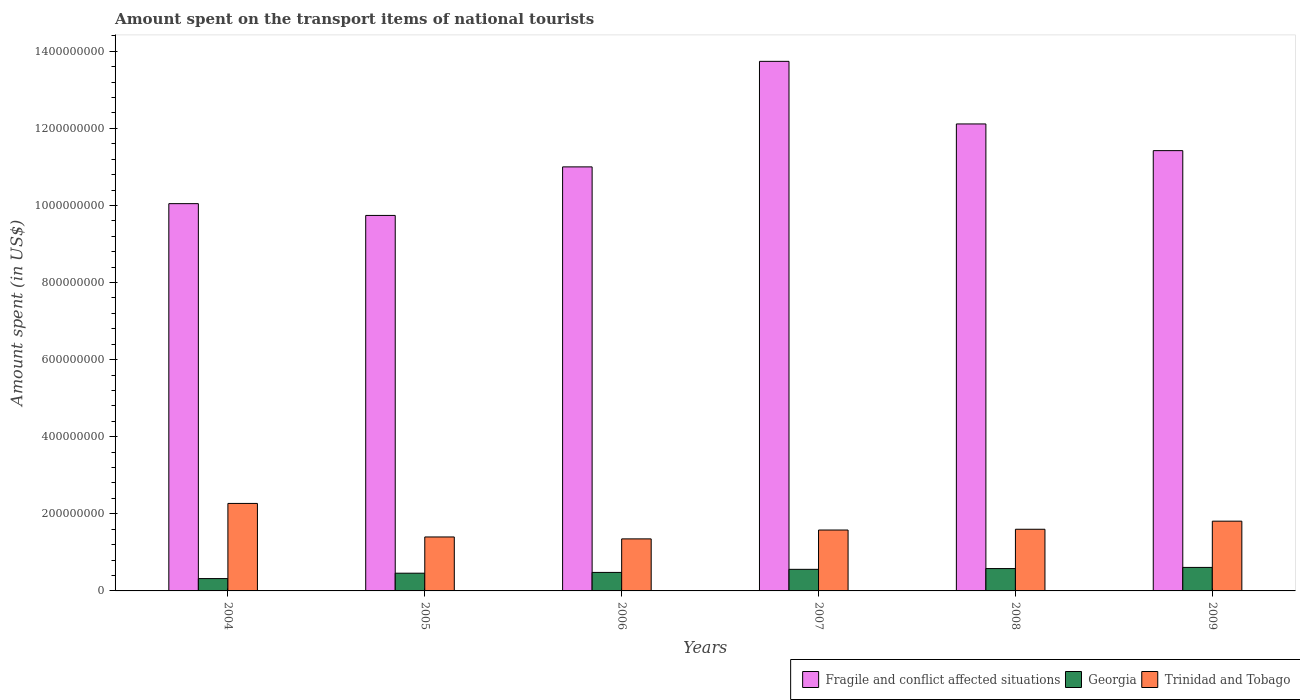Are the number of bars per tick equal to the number of legend labels?
Your answer should be very brief. Yes. How many bars are there on the 6th tick from the right?
Offer a terse response. 3. In how many cases, is the number of bars for a given year not equal to the number of legend labels?
Keep it short and to the point. 0. What is the amount spent on the transport items of national tourists in Georgia in 2005?
Provide a succinct answer. 4.60e+07. Across all years, what is the maximum amount spent on the transport items of national tourists in Fragile and conflict affected situations?
Your response must be concise. 1.37e+09. Across all years, what is the minimum amount spent on the transport items of national tourists in Georgia?
Keep it short and to the point. 3.20e+07. In which year was the amount spent on the transport items of national tourists in Trinidad and Tobago maximum?
Keep it short and to the point. 2004. In which year was the amount spent on the transport items of national tourists in Fragile and conflict affected situations minimum?
Offer a terse response. 2005. What is the total amount spent on the transport items of national tourists in Trinidad and Tobago in the graph?
Ensure brevity in your answer.  1.00e+09. What is the difference between the amount spent on the transport items of national tourists in Georgia in 2007 and the amount spent on the transport items of national tourists in Fragile and conflict affected situations in 2004?
Your answer should be compact. -9.49e+08. What is the average amount spent on the transport items of national tourists in Fragile and conflict affected situations per year?
Ensure brevity in your answer.  1.13e+09. In the year 2009, what is the difference between the amount spent on the transport items of national tourists in Trinidad and Tobago and amount spent on the transport items of national tourists in Georgia?
Ensure brevity in your answer.  1.20e+08. In how many years, is the amount spent on the transport items of national tourists in Georgia greater than 560000000 US$?
Provide a succinct answer. 0. What is the ratio of the amount spent on the transport items of national tourists in Trinidad and Tobago in 2005 to that in 2008?
Provide a succinct answer. 0.88. Is the amount spent on the transport items of national tourists in Fragile and conflict affected situations in 2008 less than that in 2009?
Your answer should be compact. No. Is the difference between the amount spent on the transport items of national tourists in Trinidad and Tobago in 2006 and 2008 greater than the difference between the amount spent on the transport items of national tourists in Georgia in 2006 and 2008?
Your answer should be very brief. No. What is the difference between the highest and the second highest amount spent on the transport items of national tourists in Fragile and conflict affected situations?
Your answer should be compact. 1.62e+08. What is the difference between the highest and the lowest amount spent on the transport items of national tourists in Georgia?
Ensure brevity in your answer.  2.90e+07. In how many years, is the amount spent on the transport items of national tourists in Trinidad and Tobago greater than the average amount spent on the transport items of national tourists in Trinidad and Tobago taken over all years?
Offer a very short reply. 2. Is the sum of the amount spent on the transport items of national tourists in Trinidad and Tobago in 2004 and 2008 greater than the maximum amount spent on the transport items of national tourists in Georgia across all years?
Your answer should be compact. Yes. What does the 2nd bar from the left in 2005 represents?
Your response must be concise. Georgia. What does the 2nd bar from the right in 2004 represents?
Your answer should be compact. Georgia. Is it the case that in every year, the sum of the amount spent on the transport items of national tourists in Georgia and amount spent on the transport items of national tourists in Trinidad and Tobago is greater than the amount spent on the transport items of national tourists in Fragile and conflict affected situations?
Ensure brevity in your answer.  No. How many bars are there?
Provide a succinct answer. 18. Are all the bars in the graph horizontal?
Provide a short and direct response. No. How many years are there in the graph?
Your response must be concise. 6. Are the values on the major ticks of Y-axis written in scientific E-notation?
Provide a short and direct response. No. What is the title of the graph?
Your response must be concise. Amount spent on the transport items of national tourists. Does "Bahamas" appear as one of the legend labels in the graph?
Provide a succinct answer. No. What is the label or title of the X-axis?
Offer a very short reply. Years. What is the label or title of the Y-axis?
Give a very brief answer. Amount spent (in US$). What is the Amount spent (in US$) in Fragile and conflict affected situations in 2004?
Provide a short and direct response. 1.00e+09. What is the Amount spent (in US$) of Georgia in 2004?
Your answer should be compact. 3.20e+07. What is the Amount spent (in US$) of Trinidad and Tobago in 2004?
Give a very brief answer. 2.27e+08. What is the Amount spent (in US$) in Fragile and conflict affected situations in 2005?
Your answer should be compact. 9.74e+08. What is the Amount spent (in US$) of Georgia in 2005?
Provide a succinct answer. 4.60e+07. What is the Amount spent (in US$) of Trinidad and Tobago in 2005?
Provide a short and direct response. 1.40e+08. What is the Amount spent (in US$) of Fragile and conflict affected situations in 2006?
Offer a very short reply. 1.10e+09. What is the Amount spent (in US$) in Georgia in 2006?
Your response must be concise. 4.80e+07. What is the Amount spent (in US$) in Trinidad and Tobago in 2006?
Ensure brevity in your answer.  1.35e+08. What is the Amount spent (in US$) in Fragile and conflict affected situations in 2007?
Your response must be concise. 1.37e+09. What is the Amount spent (in US$) in Georgia in 2007?
Keep it short and to the point. 5.60e+07. What is the Amount spent (in US$) of Trinidad and Tobago in 2007?
Your response must be concise. 1.58e+08. What is the Amount spent (in US$) in Fragile and conflict affected situations in 2008?
Give a very brief answer. 1.21e+09. What is the Amount spent (in US$) in Georgia in 2008?
Your answer should be compact. 5.80e+07. What is the Amount spent (in US$) in Trinidad and Tobago in 2008?
Your answer should be compact. 1.60e+08. What is the Amount spent (in US$) of Fragile and conflict affected situations in 2009?
Give a very brief answer. 1.14e+09. What is the Amount spent (in US$) of Georgia in 2009?
Your answer should be compact. 6.10e+07. What is the Amount spent (in US$) of Trinidad and Tobago in 2009?
Provide a succinct answer. 1.81e+08. Across all years, what is the maximum Amount spent (in US$) of Fragile and conflict affected situations?
Keep it short and to the point. 1.37e+09. Across all years, what is the maximum Amount spent (in US$) in Georgia?
Your answer should be compact. 6.10e+07. Across all years, what is the maximum Amount spent (in US$) of Trinidad and Tobago?
Keep it short and to the point. 2.27e+08. Across all years, what is the minimum Amount spent (in US$) of Fragile and conflict affected situations?
Provide a short and direct response. 9.74e+08. Across all years, what is the minimum Amount spent (in US$) in Georgia?
Keep it short and to the point. 3.20e+07. Across all years, what is the minimum Amount spent (in US$) of Trinidad and Tobago?
Make the answer very short. 1.35e+08. What is the total Amount spent (in US$) in Fragile and conflict affected situations in the graph?
Your answer should be compact. 6.81e+09. What is the total Amount spent (in US$) of Georgia in the graph?
Make the answer very short. 3.01e+08. What is the total Amount spent (in US$) in Trinidad and Tobago in the graph?
Keep it short and to the point. 1.00e+09. What is the difference between the Amount spent (in US$) of Fragile and conflict affected situations in 2004 and that in 2005?
Make the answer very short. 3.06e+07. What is the difference between the Amount spent (in US$) of Georgia in 2004 and that in 2005?
Your answer should be compact. -1.40e+07. What is the difference between the Amount spent (in US$) in Trinidad and Tobago in 2004 and that in 2005?
Your answer should be very brief. 8.70e+07. What is the difference between the Amount spent (in US$) of Fragile and conflict affected situations in 2004 and that in 2006?
Offer a terse response. -9.54e+07. What is the difference between the Amount spent (in US$) in Georgia in 2004 and that in 2006?
Your answer should be very brief. -1.60e+07. What is the difference between the Amount spent (in US$) in Trinidad and Tobago in 2004 and that in 2006?
Make the answer very short. 9.20e+07. What is the difference between the Amount spent (in US$) in Fragile and conflict affected situations in 2004 and that in 2007?
Provide a succinct answer. -3.69e+08. What is the difference between the Amount spent (in US$) of Georgia in 2004 and that in 2007?
Provide a succinct answer. -2.40e+07. What is the difference between the Amount spent (in US$) of Trinidad and Tobago in 2004 and that in 2007?
Offer a terse response. 6.90e+07. What is the difference between the Amount spent (in US$) of Fragile and conflict affected situations in 2004 and that in 2008?
Ensure brevity in your answer.  -2.07e+08. What is the difference between the Amount spent (in US$) of Georgia in 2004 and that in 2008?
Provide a succinct answer. -2.60e+07. What is the difference between the Amount spent (in US$) of Trinidad and Tobago in 2004 and that in 2008?
Provide a succinct answer. 6.70e+07. What is the difference between the Amount spent (in US$) in Fragile and conflict affected situations in 2004 and that in 2009?
Your response must be concise. -1.38e+08. What is the difference between the Amount spent (in US$) of Georgia in 2004 and that in 2009?
Provide a succinct answer. -2.90e+07. What is the difference between the Amount spent (in US$) of Trinidad and Tobago in 2004 and that in 2009?
Your answer should be very brief. 4.60e+07. What is the difference between the Amount spent (in US$) of Fragile and conflict affected situations in 2005 and that in 2006?
Ensure brevity in your answer.  -1.26e+08. What is the difference between the Amount spent (in US$) of Georgia in 2005 and that in 2006?
Make the answer very short. -2.00e+06. What is the difference between the Amount spent (in US$) in Trinidad and Tobago in 2005 and that in 2006?
Give a very brief answer. 5.00e+06. What is the difference between the Amount spent (in US$) in Fragile and conflict affected situations in 2005 and that in 2007?
Provide a short and direct response. -4.00e+08. What is the difference between the Amount spent (in US$) of Georgia in 2005 and that in 2007?
Your answer should be compact. -1.00e+07. What is the difference between the Amount spent (in US$) in Trinidad and Tobago in 2005 and that in 2007?
Keep it short and to the point. -1.80e+07. What is the difference between the Amount spent (in US$) of Fragile and conflict affected situations in 2005 and that in 2008?
Give a very brief answer. -2.37e+08. What is the difference between the Amount spent (in US$) of Georgia in 2005 and that in 2008?
Keep it short and to the point. -1.20e+07. What is the difference between the Amount spent (in US$) of Trinidad and Tobago in 2005 and that in 2008?
Your answer should be very brief. -2.00e+07. What is the difference between the Amount spent (in US$) in Fragile and conflict affected situations in 2005 and that in 2009?
Offer a very short reply. -1.68e+08. What is the difference between the Amount spent (in US$) in Georgia in 2005 and that in 2009?
Your answer should be very brief. -1.50e+07. What is the difference between the Amount spent (in US$) in Trinidad and Tobago in 2005 and that in 2009?
Make the answer very short. -4.10e+07. What is the difference between the Amount spent (in US$) in Fragile and conflict affected situations in 2006 and that in 2007?
Offer a very short reply. -2.74e+08. What is the difference between the Amount spent (in US$) of Georgia in 2006 and that in 2007?
Keep it short and to the point. -8.00e+06. What is the difference between the Amount spent (in US$) of Trinidad and Tobago in 2006 and that in 2007?
Keep it short and to the point. -2.30e+07. What is the difference between the Amount spent (in US$) in Fragile and conflict affected situations in 2006 and that in 2008?
Your answer should be very brief. -1.11e+08. What is the difference between the Amount spent (in US$) of Georgia in 2006 and that in 2008?
Provide a succinct answer. -1.00e+07. What is the difference between the Amount spent (in US$) in Trinidad and Tobago in 2006 and that in 2008?
Provide a succinct answer. -2.50e+07. What is the difference between the Amount spent (in US$) in Fragile and conflict affected situations in 2006 and that in 2009?
Your answer should be very brief. -4.22e+07. What is the difference between the Amount spent (in US$) in Georgia in 2006 and that in 2009?
Give a very brief answer. -1.30e+07. What is the difference between the Amount spent (in US$) in Trinidad and Tobago in 2006 and that in 2009?
Your answer should be compact. -4.60e+07. What is the difference between the Amount spent (in US$) in Fragile and conflict affected situations in 2007 and that in 2008?
Provide a succinct answer. 1.62e+08. What is the difference between the Amount spent (in US$) of Georgia in 2007 and that in 2008?
Provide a short and direct response. -2.00e+06. What is the difference between the Amount spent (in US$) in Fragile and conflict affected situations in 2007 and that in 2009?
Ensure brevity in your answer.  2.32e+08. What is the difference between the Amount spent (in US$) in Georgia in 2007 and that in 2009?
Provide a succinct answer. -5.00e+06. What is the difference between the Amount spent (in US$) of Trinidad and Tobago in 2007 and that in 2009?
Ensure brevity in your answer.  -2.30e+07. What is the difference between the Amount spent (in US$) of Fragile and conflict affected situations in 2008 and that in 2009?
Your response must be concise. 6.92e+07. What is the difference between the Amount spent (in US$) in Georgia in 2008 and that in 2009?
Your response must be concise. -3.00e+06. What is the difference between the Amount spent (in US$) in Trinidad and Tobago in 2008 and that in 2009?
Your answer should be very brief. -2.10e+07. What is the difference between the Amount spent (in US$) in Fragile and conflict affected situations in 2004 and the Amount spent (in US$) in Georgia in 2005?
Provide a succinct answer. 9.59e+08. What is the difference between the Amount spent (in US$) in Fragile and conflict affected situations in 2004 and the Amount spent (in US$) in Trinidad and Tobago in 2005?
Offer a very short reply. 8.65e+08. What is the difference between the Amount spent (in US$) in Georgia in 2004 and the Amount spent (in US$) in Trinidad and Tobago in 2005?
Your answer should be compact. -1.08e+08. What is the difference between the Amount spent (in US$) in Fragile and conflict affected situations in 2004 and the Amount spent (in US$) in Georgia in 2006?
Provide a succinct answer. 9.57e+08. What is the difference between the Amount spent (in US$) in Fragile and conflict affected situations in 2004 and the Amount spent (in US$) in Trinidad and Tobago in 2006?
Keep it short and to the point. 8.70e+08. What is the difference between the Amount spent (in US$) in Georgia in 2004 and the Amount spent (in US$) in Trinidad and Tobago in 2006?
Offer a terse response. -1.03e+08. What is the difference between the Amount spent (in US$) of Fragile and conflict affected situations in 2004 and the Amount spent (in US$) of Georgia in 2007?
Keep it short and to the point. 9.49e+08. What is the difference between the Amount spent (in US$) of Fragile and conflict affected situations in 2004 and the Amount spent (in US$) of Trinidad and Tobago in 2007?
Make the answer very short. 8.47e+08. What is the difference between the Amount spent (in US$) of Georgia in 2004 and the Amount spent (in US$) of Trinidad and Tobago in 2007?
Make the answer very short. -1.26e+08. What is the difference between the Amount spent (in US$) in Fragile and conflict affected situations in 2004 and the Amount spent (in US$) in Georgia in 2008?
Make the answer very short. 9.47e+08. What is the difference between the Amount spent (in US$) in Fragile and conflict affected situations in 2004 and the Amount spent (in US$) in Trinidad and Tobago in 2008?
Your answer should be very brief. 8.45e+08. What is the difference between the Amount spent (in US$) of Georgia in 2004 and the Amount spent (in US$) of Trinidad and Tobago in 2008?
Keep it short and to the point. -1.28e+08. What is the difference between the Amount spent (in US$) in Fragile and conflict affected situations in 2004 and the Amount spent (in US$) in Georgia in 2009?
Your answer should be very brief. 9.44e+08. What is the difference between the Amount spent (in US$) of Fragile and conflict affected situations in 2004 and the Amount spent (in US$) of Trinidad and Tobago in 2009?
Provide a succinct answer. 8.24e+08. What is the difference between the Amount spent (in US$) in Georgia in 2004 and the Amount spent (in US$) in Trinidad and Tobago in 2009?
Give a very brief answer. -1.49e+08. What is the difference between the Amount spent (in US$) of Fragile and conflict affected situations in 2005 and the Amount spent (in US$) of Georgia in 2006?
Offer a terse response. 9.26e+08. What is the difference between the Amount spent (in US$) in Fragile and conflict affected situations in 2005 and the Amount spent (in US$) in Trinidad and Tobago in 2006?
Offer a very short reply. 8.39e+08. What is the difference between the Amount spent (in US$) in Georgia in 2005 and the Amount spent (in US$) in Trinidad and Tobago in 2006?
Keep it short and to the point. -8.90e+07. What is the difference between the Amount spent (in US$) in Fragile and conflict affected situations in 2005 and the Amount spent (in US$) in Georgia in 2007?
Your answer should be very brief. 9.18e+08. What is the difference between the Amount spent (in US$) of Fragile and conflict affected situations in 2005 and the Amount spent (in US$) of Trinidad and Tobago in 2007?
Your answer should be compact. 8.16e+08. What is the difference between the Amount spent (in US$) of Georgia in 2005 and the Amount spent (in US$) of Trinidad and Tobago in 2007?
Keep it short and to the point. -1.12e+08. What is the difference between the Amount spent (in US$) in Fragile and conflict affected situations in 2005 and the Amount spent (in US$) in Georgia in 2008?
Provide a succinct answer. 9.16e+08. What is the difference between the Amount spent (in US$) of Fragile and conflict affected situations in 2005 and the Amount spent (in US$) of Trinidad and Tobago in 2008?
Make the answer very short. 8.14e+08. What is the difference between the Amount spent (in US$) of Georgia in 2005 and the Amount spent (in US$) of Trinidad and Tobago in 2008?
Your response must be concise. -1.14e+08. What is the difference between the Amount spent (in US$) in Fragile and conflict affected situations in 2005 and the Amount spent (in US$) in Georgia in 2009?
Your answer should be compact. 9.13e+08. What is the difference between the Amount spent (in US$) in Fragile and conflict affected situations in 2005 and the Amount spent (in US$) in Trinidad and Tobago in 2009?
Keep it short and to the point. 7.93e+08. What is the difference between the Amount spent (in US$) in Georgia in 2005 and the Amount spent (in US$) in Trinidad and Tobago in 2009?
Make the answer very short. -1.35e+08. What is the difference between the Amount spent (in US$) in Fragile and conflict affected situations in 2006 and the Amount spent (in US$) in Georgia in 2007?
Your response must be concise. 1.04e+09. What is the difference between the Amount spent (in US$) in Fragile and conflict affected situations in 2006 and the Amount spent (in US$) in Trinidad and Tobago in 2007?
Offer a terse response. 9.42e+08. What is the difference between the Amount spent (in US$) of Georgia in 2006 and the Amount spent (in US$) of Trinidad and Tobago in 2007?
Offer a very short reply. -1.10e+08. What is the difference between the Amount spent (in US$) in Fragile and conflict affected situations in 2006 and the Amount spent (in US$) in Georgia in 2008?
Offer a terse response. 1.04e+09. What is the difference between the Amount spent (in US$) of Fragile and conflict affected situations in 2006 and the Amount spent (in US$) of Trinidad and Tobago in 2008?
Your response must be concise. 9.40e+08. What is the difference between the Amount spent (in US$) in Georgia in 2006 and the Amount spent (in US$) in Trinidad and Tobago in 2008?
Your response must be concise. -1.12e+08. What is the difference between the Amount spent (in US$) in Fragile and conflict affected situations in 2006 and the Amount spent (in US$) in Georgia in 2009?
Give a very brief answer. 1.04e+09. What is the difference between the Amount spent (in US$) of Fragile and conflict affected situations in 2006 and the Amount spent (in US$) of Trinidad and Tobago in 2009?
Ensure brevity in your answer.  9.19e+08. What is the difference between the Amount spent (in US$) of Georgia in 2006 and the Amount spent (in US$) of Trinidad and Tobago in 2009?
Provide a succinct answer. -1.33e+08. What is the difference between the Amount spent (in US$) of Fragile and conflict affected situations in 2007 and the Amount spent (in US$) of Georgia in 2008?
Provide a short and direct response. 1.32e+09. What is the difference between the Amount spent (in US$) of Fragile and conflict affected situations in 2007 and the Amount spent (in US$) of Trinidad and Tobago in 2008?
Provide a succinct answer. 1.21e+09. What is the difference between the Amount spent (in US$) in Georgia in 2007 and the Amount spent (in US$) in Trinidad and Tobago in 2008?
Make the answer very short. -1.04e+08. What is the difference between the Amount spent (in US$) of Fragile and conflict affected situations in 2007 and the Amount spent (in US$) of Georgia in 2009?
Ensure brevity in your answer.  1.31e+09. What is the difference between the Amount spent (in US$) in Fragile and conflict affected situations in 2007 and the Amount spent (in US$) in Trinidad and Tobago in 2009?
Offer a very short reply. 1.19e+09. What is the difference between the Amount spent (in US$) of Georgia in 2007 and the Amount spent (in US$) of Trinidad and Tobago in 2009?
Keep it short and to the point. -1.25e+08. What is the difference between the Amount spent (in US$) of Fragile and conflict affected situations in 2008 and the Amount spent (in US$) of Georgia in 2009?
Offer a very short reply. 1.15e+09. What is the difference between the Amount spent (in US$) in Fragile and conflict affected situations in 2008 and the Amount spent (in US$) in Trinidad and Tobago in 2009?
Keep it short and to the point. 1.03e+09. What is the difference between the Amount spent (in US$) of Georgia in 2008 and the Amount spent (in US$) of Trinidad and Tobago in 2009?
Offer a very short reply. -1.23e+08. What is the average Amount spent (in US$) of Fragile and conflict affected situations per year?
Provide a succinct answer. 1.13e+09. What is the average Amount spent (in US$) in Georgia per year?
Your answer should be compact. 5.02e+07. What is the average Amount spent (in US$) of Trinidad and Tobago per year?
Your answer should be very brief. 1.67e+08. In the year 2004, what is the difference between the Amount spent (in US$) of Fragile and conflict affected situations and Amount spent (in US$) of Georgia?
Your answer should be very brief. 9.73e+08. In the year 2004, what is the difference between the Amount spent (in US$) of Fragile and conflict affected situations and Amount spent (in US$) of Trinidad and Tobago?
Offer a terse response. 7.78e+08. In the year 2004, what is the difference between the Amount spent (in US$) in Georgia and Amount spent (in US$) in Trinidad and Tobago?
Provide a short and direct response. -1.95e+08. In the year 2005, what is the difference between the Amount spent (in US$) in Fragile and conflict affected situations and Amount spent (in US$) in Georgia?
Provide a succinct answer. 9.28e+08. In the year 2005, what is the difference between the Amount spent (in US$) of Fragile and conflict affected situations and Amount spent (in US$) of Trinidad and Tobago?
Give a very brief answer. 8.34e+08. In the year 2005, what is the difference between the Amount spent (in US$) of Georgia and Amount spent (in US$) of Trinidad and Tobago?
Your answer should be compact. -9.40e+07. In the year 2006, what is the difference between the Amount spent (in US$) in Fragile and conflict affected situations and Amount spent (in US$) in Georgia?
Offer a very short reply. 1.05e+09. In the year 2006, what is the difference between the Amount spent (in US$) of Fragile and conflict affected situations and Amount spent (in US$) of Trinidad and Tobago?
Keep it short and to the point. 9.65e+08. In the year 2006, what is the difference between the Amount spent (in US$) of Georgia and Amount spent (in US$) of Trinidad and Tobago?
Keep it short and to the point. -8.70e+07. In the year 2007, what is the difference between the Amount spent (in US$) of Fragile and conflict affected situations and Amount spent (in US$) of Georgia?
Provide a succinct answer. 1.32e+09. In the year 2007, what is the difference between the Amount spent (in US$) of Fragile and conflict affected situations and Amount spent (in US$) of Trinidad and Tobago?
Ensure brevity in your answer.  1.22e+09. In the year 2007, what is the difference between the Amount spent (in US$) of Georgia and Amount spent (in US$) of Trinidad and Tobago?
Offer a very short reply. -1.02e+08. In the year 2008, what is the difference between the Amount spent (in US$) in Fragile and conflict affected situations and Amount spent (in US$) in Georgia?
Make the answer very short. 1.15e+09. In the year 2008, what is the difference between the Amount spent (in US$) in Fragile and conflict affected situations and Amount spent (in US$) in Trinidad and Tobago?
Keep it short and to the point. 1.05e+09. In the year 2008, what is the difference between the Amount spent (in US$) in Georgia and Amount spent (in US$) in Trinidad and Tobago?
Make the answer very short. -1.02e+08. In the year 2009, what is the difference between the Amount spent (in US$) in Fragile and conflict affected situations and Amount spent (in US$) in Georgia?
Keep it short and to the point. 1.08e+09. In the year 2009, what is the difference between the Amount spent (in US$) in Fragile and conflict affected situations and Amount spent (in US$) in Trinidad and Tobago?
Your answer should be compact. 9.61e+08. In the year 2009, what is the difference between the Amount spent (in US$) in Georgia and Amount spent (in US$) in Trinidad and Tobago?
Make the answer very short. -1.20e+08. What is the ratio of the Amount spent (in US$) in Fragile and conflict affected situations in 2004 to that in 2005?
Provide a succinct answer. 1.03. What is the ratio of the Amount spent (in US$) in Georgia in 2004 to that in 2005?
Make the answer very short. 0.7. What is the ratio of the Amount spent (in US$) in Trinidad and Tobago in 2004 to that in 2005?
Your response must be concise. 1.62. What is the ratio of the Amount spent (in US$) of Fragile and conflict affected situations in 2004 to that in 2006?
Provide a short and direct response. 0.91. What is the ratio of the Amount spent (in US$) of Trinidad and Tobago in 2004 to that in 2006?
Make the answer very short. 1.68. What is the ratio of the Amount spent (in US$) of Fragile and conflict affected situations in 2004 to that in 2007?
Provide a succinct answer. 0.73. What is the ratio of the Amount spent (in US$) of Georgia in 2004 to that in 2007?
Your answer should be very brief. 0.57. What is the ratio of the Amount spent (in US$) of Trinidad and Tobago in 2004 to that in 2007?
Offer a very short reply. 1.44. What is the ratio of the Amount spent (in US$) in Fragile and conflict affected situations in 2004 to that in 2008?
Your answer should be compact. 0.83. What is the ratio of the Amount spent (in US$) of Georgia in 2004 to that in 2008?
Ensure brevity in your answer.  0.55. What is the ratio of the Amount spent (in US$) in Trinidad and Tobago in 2004 to that in 2008?
Keep it short and to the point. 1.42. What is the ratio of the Amount spent (in US$) in Fragile and conflict affected situations in 2004 to that in 2009?
Ensure brevity in your answer.  0.88. What is the ratio of the Amount spent (in US$) of Georgia in 2004 to that in 2009?
Offer a very short reply. 0.52. What is the ratio of the Amount spent (in US$) in Trinidad and Tobago in 2004 to that in 2009?
Offer a terse response. 1.25. What is the ratio of the Amount spent (in US$) in Fragile and conflict affected situations in 2005 to that in 2006?
Offer a very short reply. 0.89. What is the ratio of the Amount spent (in US$) of Trinidad and Tobago in 2005 to that in 2006?
Offer a terse response. 1.04. What is the ratio of the Amount spent (in US$) of Fragile and conflict affected situations in 2005 to that in 2007?
Your answer should be compact. 0.71. What is the ratio of the Amount spent (in US$) of Georgia in 2005 to that in 2007?
Offer a terse response. 0.82. What is the ratio of the Amount spent (in US$) in Trinidad and Tobago in 2005 to that in 2007?
Keep it short and to the point. 0.89. What is the ratio of the Amount spent (in US$) of Fragile and conflict affected situations in 2005 to that in 2008?
Keep it short and to the point. 0.8. What is the ratio of the Amount spent (in US$) of Georgia in 2005 to that in 2008?
Offer a terse response. 0.79. What is the ratio of the Amount spent (in US$) of Fragile and conflict affected situations in 2005 to that in 2009?
Offer a terse response. 0.85. What is the ratio of the Amount spent (in US$) of Georgia in 2005 to that in 2009?
Your response must be concise. 0.75. What is the ratio of the Amount spent (in US$) in Trinidad and Tobago in 2005 to that in 2009?
Give a very brief answer. 0.77. What is the ratio of the Amount spent (in US$) of Fragile and conflict affected situations in 2006 to that in 2007?
Ensure brevity in your answer.  0.8. What is the ratio of the Amount spent (in US$) of Georgia in 2006 to that in 2007?
Offer a very short reply. 0.86. What is the ratio of the Amount spent (in US$) in Trinidad and Tobago in 2006 to that in 2007?
Your answer should be compact. 0.85. What is the ratio of the Amount spent (in US$) of Fragile and conflict affected situations in 2006 to that in 2008?
Ensure brevity in your answer.  0.91. What is the ratio of the Amount spent (in US$) of Georgia in 2006 to that in 2008?
Provide a succinct answer. 0.83. What is the ratio of the Amount spent (in US$) in Trinidad and Tobago in 2006 to that in 2008?
Your answer should be very brief. 0.84. What is the ratio of the Amount spent (in US$) of Fragile and conflict affected situations in 2006 to that in 2009?
Ensure brevity in your answer.  0.96. What is the ratio of the Amount spent (in US$) of Georgia in 2006 to that in 2009?
Ensure brevity in your answer.  0.79. What is the ratio of the Amount spent (in US$) of Trinidad and Tobago in 2006 to that in 2009?
Provide a short and direct response. 0.75. What is the ratio of the Amount spent (in US$) in Fragile and conflict affected situations in 2007 to that in 2008?
Offer a terse response. 1.13. What is the ratio of the Amount spent (in US$) in Georgia in 2007 to that in 2008?
Offer a terse response. 0.97. What is the ratio of the Amount spent (in US$) in Trinidad and Tobago in 2007 to that in 2008?
Provide a short and direct response. 0.99. What is the ratio of the Amount spent (in US$) in Fragile and conflict affected situations in 2007 to that in 2009?
Keep it short and to the point. 1.2. What is the ratio of the Amount spent (in US$) of Georgia in 2007 to that in 2009?
Your response must be concise. 0.92. What is the ratio of the Amount spent (in US$) of Trinidad and Tobago in 2007 to that in 2009?
Your response must be concise. 0.87. What is the ratio of the Amount spent (in US$) in Fragile and conflict affected situations in 2008 to that in 2009?
Ensure brevity in your answer.  1.06. What is the ratio of the Amount spent (in US$) in Georgia in 2008 to that in 2009?
Your answer should be compact. 0.95. What is the ratio of the Amount spent (in US$) in Trinidad and Tobago in 2008 to that in 2009?
Ensure brevity in your answer.  0.88. What is the difference between the highest and the second highest Amount spent (in US$) of Fragile and conflict affected situations?
Provide a short and direct response. 1.62e+08. What is the difference between the highest and the second highest Amount spent (in US$) of Georgia?
Offer a terse response. 3.00e+06. What is the difference between the highest and the second highest Amount spent (in US$) of Trinidad and Tobago?
Your answer should be compact. 4.60e+07. What is the difference between the highest and the lowest Amount spent (in US$) in Fragile and conflict affected situations?
Provide a short and direct response. 4.00e+08. What is the difference between the highest and the lowest Amount spent (in US$) of Georgia?
Keep it short and to the point. 2.90e+07. What is the difference between the highest and the lowest Amount spent (in US$) of Trinidad and Tobago?
Offer a terse response. 9.20e+07. 